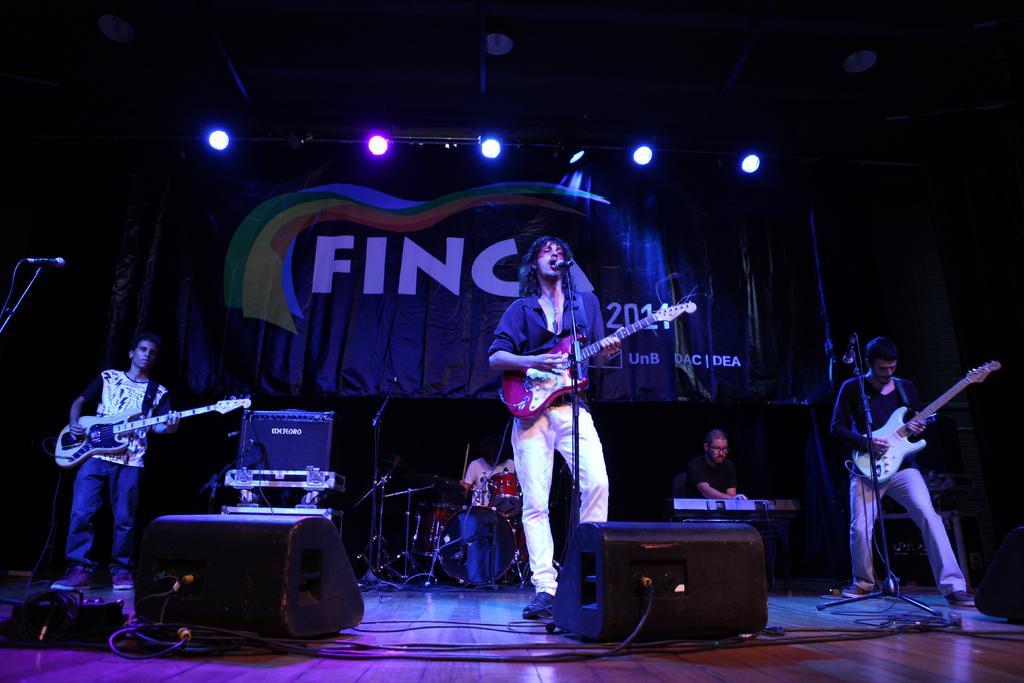In one or two sentences, can you explain what this image depicts? In the image there are group of people playing their musical instruments. In middle there is a man holding a guitar and playing it and opened his mouth for singing in front of a microphone. On left side and right side there are two people playing guitar. On right side there is a another man playing a key , in middle there is a person playing his musical instrument and background there is a curtain. On top there are few lights at bottom we can see speakers and wires. 